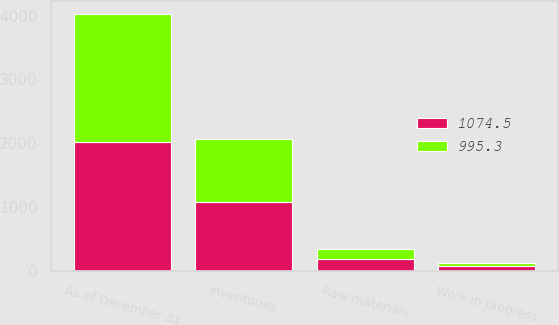<chart> <loc_0><loc_0><loc_500><loc_500><stacked_bar_chart><ecel><fcel>As of December 31<fcel>Work in progress<fcel>Raw materials<fcel>Inventories<nl><fcel>1074.5<fcel>2013<fcel>77.4<fcel>180.1<fcel>1074.5<nl><fcel>995.3<fcel>2012<fcel>52.3<fcel>156.7<fcel>995.3<nl></chart> 